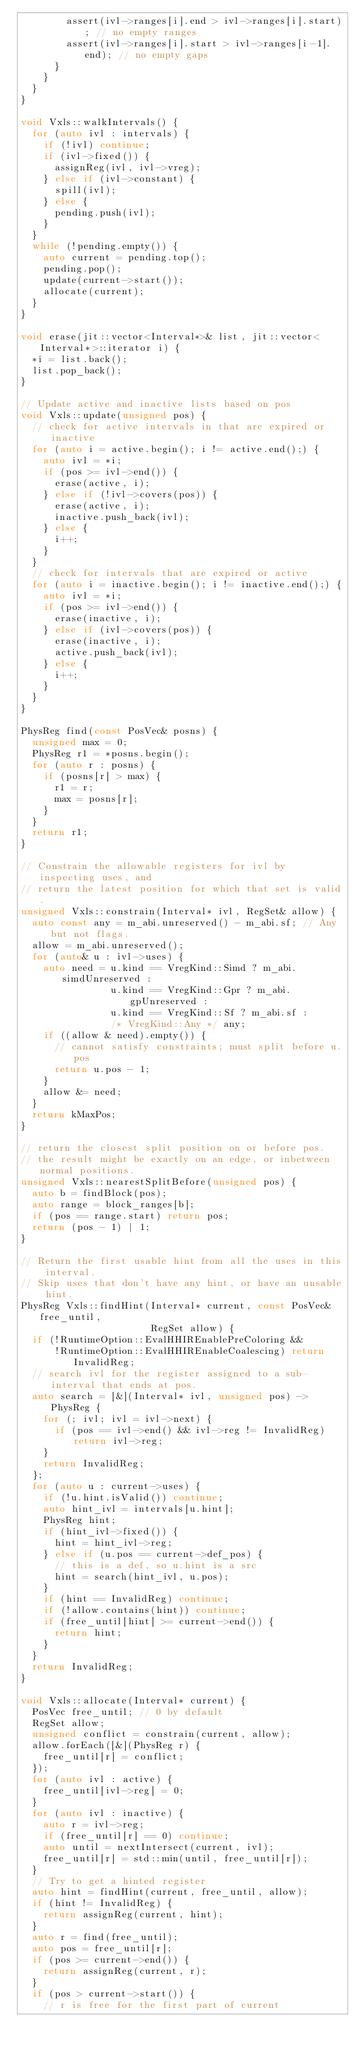<code> <loc_0><loc_0><loc_500><loc_500><_C++_>        assert(ivl->ranges[i].end > ivl->ranges[i].start); // no empty ranges
        assert(ivl->ranges[i].start > ivl->ranges[i-1].end); // no empty gaps
      }
    }
  }
}

void Vxls::walkIntervals() {
  for (auto ivl : intervals) {
    if (!ivl) continue;
    if (ivl->fixed()) {
      assignReg(ivl, ivl->vreg);
    } else if (ivl->constant) {
      spill(ivl);
    } else {
      pending.push(ivl);
    }
  }
  while (!pending.empty()) {
    auto current = pending.top();
    pending.pop();
    update(current->start());
    allocate(current);
  }
}

void erase(jit::vector<Interval*>& list, jit::vector<Interval*>::iterator i) {
  *i = list.back();
  list.pop_back();
}

// Update active and inactive lists based on pos
void Vxls::update(unsigned pos) {
  // check for active intervals in that are expired or inactive
  for (auto i = active.begin(); i != active.end();) {
    auto ivl = *i;
    if (pos >= ivl->end()) {
      erase(active, i);
    } else if (!ivl->covers(pos)) {
      erase(active, i);
      inactive.push_back(ivl);
    } else {
      i++;
    }
  }
  // check for intervals that are expired or active
  for (auto i = inactive.begin(); i != inactive.end();) {
    auto ivl = *i;
    if (pos >= ivl->end()) {
      erase(inactive, i);
    } else if (ivl->covers(pos)) {
      erase(inactive, i);
      active.push_back(ivl);
    } else {
      i++;
    }
  }
}

PhysReg find(const PosVec& posns) {
  unsigned max = 0;
  PhysReg r1 = *posns.begin();
  for (auto r : posns) {
    if (posns[r] > max) {
      r1 = r;
      max = posns[r];
    }
  }
  return r1;
}

// Constrain the allowable registers for ivl by inspecting uses, and
// return the latest position for which that set is valid.
unsigned Vxls::constrain(Interval* ivl, RegSet& allow) {
  auto const any = m_abi.unreserved() - m_abi.sf; // Any but not flags.
  allow = m_abi.unreserved();
  for (auto& u : ivl->uses) {
    auto need = u.kind == VregKind::Simd ? m_abi.simdUnreserved :
                u.kind == VregKind::Gpr ? m_abi.gpUnreserved :
                u.kind == VregKind::Sf ? m_abi.sf :
                /* VregKind::Any */ any;
    if ((allow & need).empty()) {
      // cannot satisfy constraints; must split before u.pos
      return u.pos - 1;
    }
    allow &= need;
  }
  return kMaxPos;
}

// return the closest split position on or before pos.
// the result might be exactly on an edge, or inbetween normal positions.
unsigned Vxls::nearestSplitBefore(unsigned pos) {
  auto b = findBlock(pos);
  auto range = block_ranges[b];
  if (pos == range.start) return pos;
  return (pos - 1) | 1;
}

// Return the first usable hint from all the uses in this interval.
// Skip uses that don't have any hint, or have an unsable hint.
PhysReg Vxls::findHint(Interval* current, const PosVec& free_until,
                       RegSet allow) {
  if (!RuntimeOption::EvalHHIREnablePreColoring &&
      !RuntimeOption::EvalHHIREnableCoalescing) return InvalidReg;
  // search ivl for the register assigned to a sub-interval that ends at pos.
  auto search = [&](Interval* ivl, unsigned pos) -> PhysReg {
    for (; ivl; ivl = ivl->next) {
      if (pos == ivl->end() && ivl->reg != InvalidReg) return ivl->reg;
    }
    return InvalidReg;
  };
  for (auto u : current->uses) {
    if (!u.hint.isValid()) continue;
    auto hint_ivl = intervals[u.hint];
    PhysReg hint;
    if (hint_ivl->fixed()) {
      hint = hint_ivl->reg;
    } else if (u.pos == current->def_pos) {
      // this is a def, so u.hint is a src
      hint = search(hint_ivl, u.pos);
    }
    if (hint == InvalidReg) continue;
    if (!allow.contains(hint)) continue;
    if (free_until[hint] >= current->end()) {
      return hint;
    }
  }
  return InvalidReg;
}

void Vxls::allocate(Interval* current) {
  PosVec free_until; // 0 by default
  RegSet allow;
  unsigned conflict = constrain(current, allow);
  allow.forEach([&](PhysReg r) {
    free_until[r] = conflict;
  });
  for (auto ivl : active) {
    free_until[ivl->reg] = 0;
  }
  for (auto ivl : inactive) {
    auto r = ivl->reg;
    if (free_until[r] == 0) continue;
    auto until = nextIntersect(current, ivl);
    free_until[r] = std::min(until, free_until[r]);
  }
  // Try to get a hinted register
  auto hint = findHint(current, free_until, allow);
  if (hint != InvalidReg) {
    return assignReg(current, hint);
  }
  auto r = find(free_until);
  auto pos = free_until[r];
  if (pos >= current->end()) {
    return assignReg(current, r);
  }
  if (pos > current->start()) {
    // r is free for the first part of current</code> 